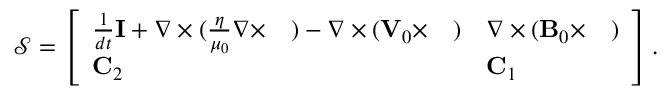<formula> <loc_0><loc_0><loc_500><loc_500>\begin{array} { r } { \mathcal { S } = \left [ \begin{array} { l l } { \frac { 1 } { d t } I + \nabla \times ( \frac { \eta } { \mu _ { 0 } } \nabla \times \quad ) - \nabla \times ( { \mathbf V } _ { 0 } \times \quad ) } & { \nabla \times ( { \mathbf B } _ { 0 } \times \quad ) } \\ { C _ { 2 } } & { C _ { 1 } } \end{array} \right ] . } \end{array}</formula> 